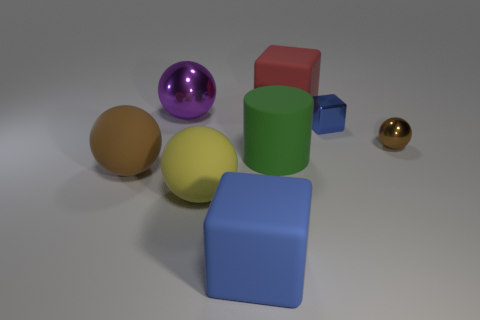Add 2 gray rubber balls. How many objects exist? 10 Subtract all big cubes. How many cubes are left? 1 Subtract all brown spheres. How many blue cubes are left? 2 Subtract all brown spheres. How many spheres are left? 2 Subtract 1 spheres. How many spheres are left? 3 Subtract all cylinders. How many objects are left? 7 Subtract all red cylinders. Subtract all cyan spheres. How many cylinders are left? 1 Subtract all brown shiny balls. Subtract all small blue cubes. How many objects are left? 6 Add 6 green matte cylinders. How many green matte cylinders are left? 7 Add 8 purple things. How many purple things exist? 9 